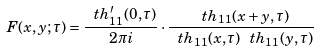Convert formula to latex. <formula><loc_0><loc_0><loc_500><loc_500>F ( x , y ; \tau ) = \frac { \ t h ^ { \prime } _ { 1 1 } ( 0 , \tau ) } { 2 \pi i } \cdot \frac { \ t h _ { 1 1 } ( x + y , \tau ) } { \ t h _ { 1 1 } ( x , \tau ) \ t h _ { 1 1 } ( y , \tau ) }</formula> 